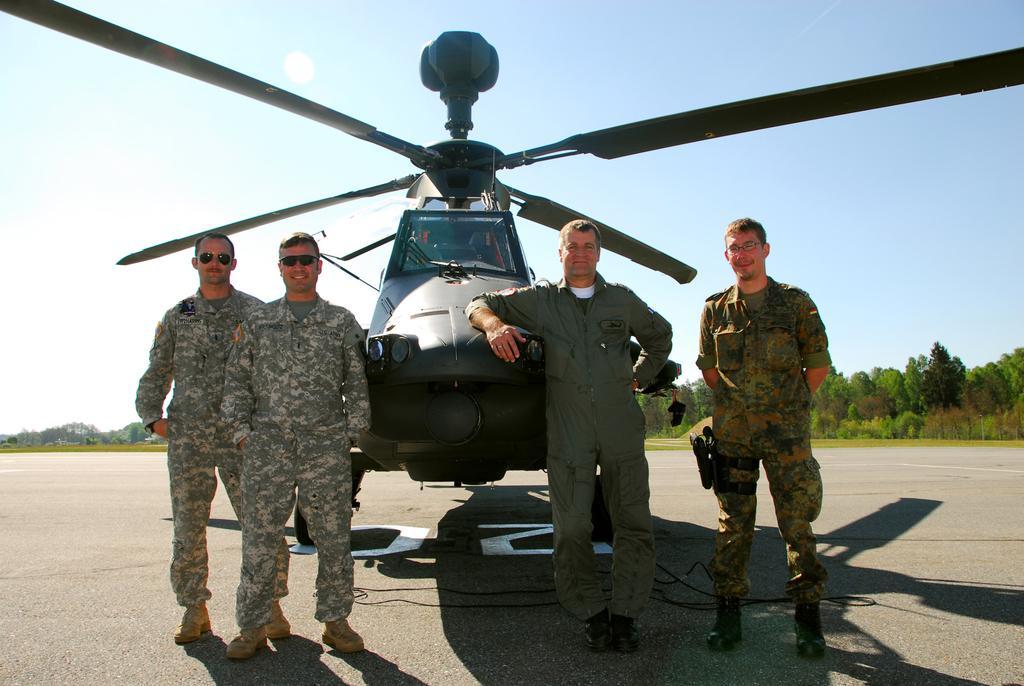Can you describe this image briefly? In this image there are some persons standing and two of them are wearing goggles, and in the center there is one helicopter. At the bottom there is road, and on the road there are some wires. In the background there are some trees and at the top of the image there is sky. 